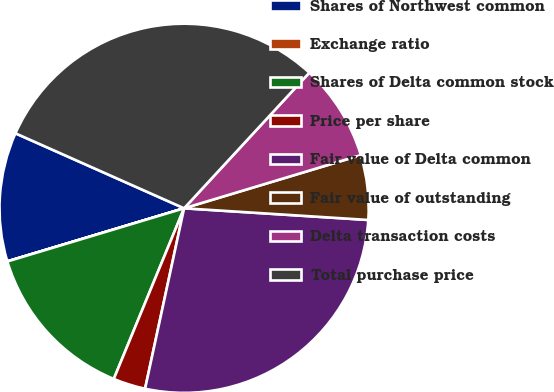<chart> <loc_0><loc_0><loc_500><loc_500><pie_chart><fcel>Shares of Northwest common<fcel>Exchange ratio<fcel>Shares of Delta common stock<fcel>Price per share<fcel>Fair value of Delta common<fcel>Fair value of outstanding<fcel>Delta transaction costs<fcel>Total purchase price<nl><fcel>11.3%<fcel>0.01%<fcel>14.13%<fcel>2.83%<fcel>27.38%<fcel>5.66%<fcel>8.48%<fcel>30.21%<nl></chart> 